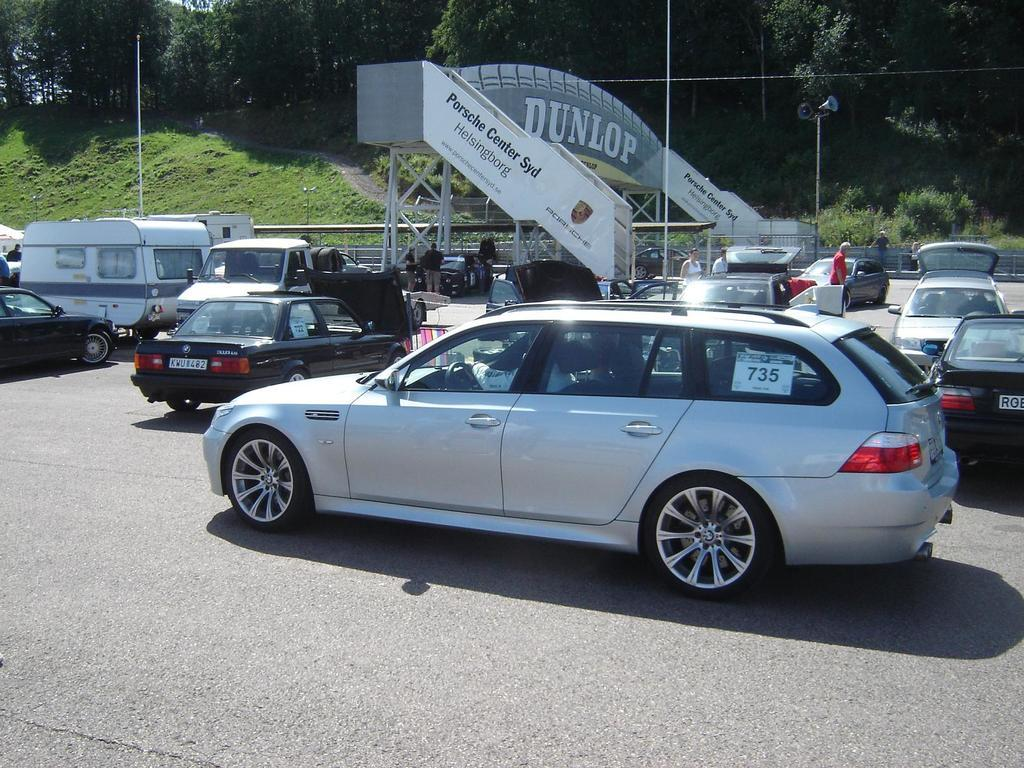What can be seen on the road in the image? There are vehicles parked on the road in the image. What is visible in the background of the image? In the background, there are people, rods and poles, grass, plants, and trees. What type of signage is present in the image? There are banners in the image. What other objects can be seen in the image? There are other objects in the image, but their specific details are not mentioned in the provided facts. What type of planes can be seen in the aftermath of the error in the image? There is no mention of planes, errors, or aftermath in the provided facts, so it is not possible to answer this question based on the image. 